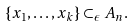<formula> <loc_0><loc_0><loc_500><loc_500>\{ x _ { 1 } , \dots , x _ { k } \} \subset _ { \epsilon } A _ { n } .</formula> 